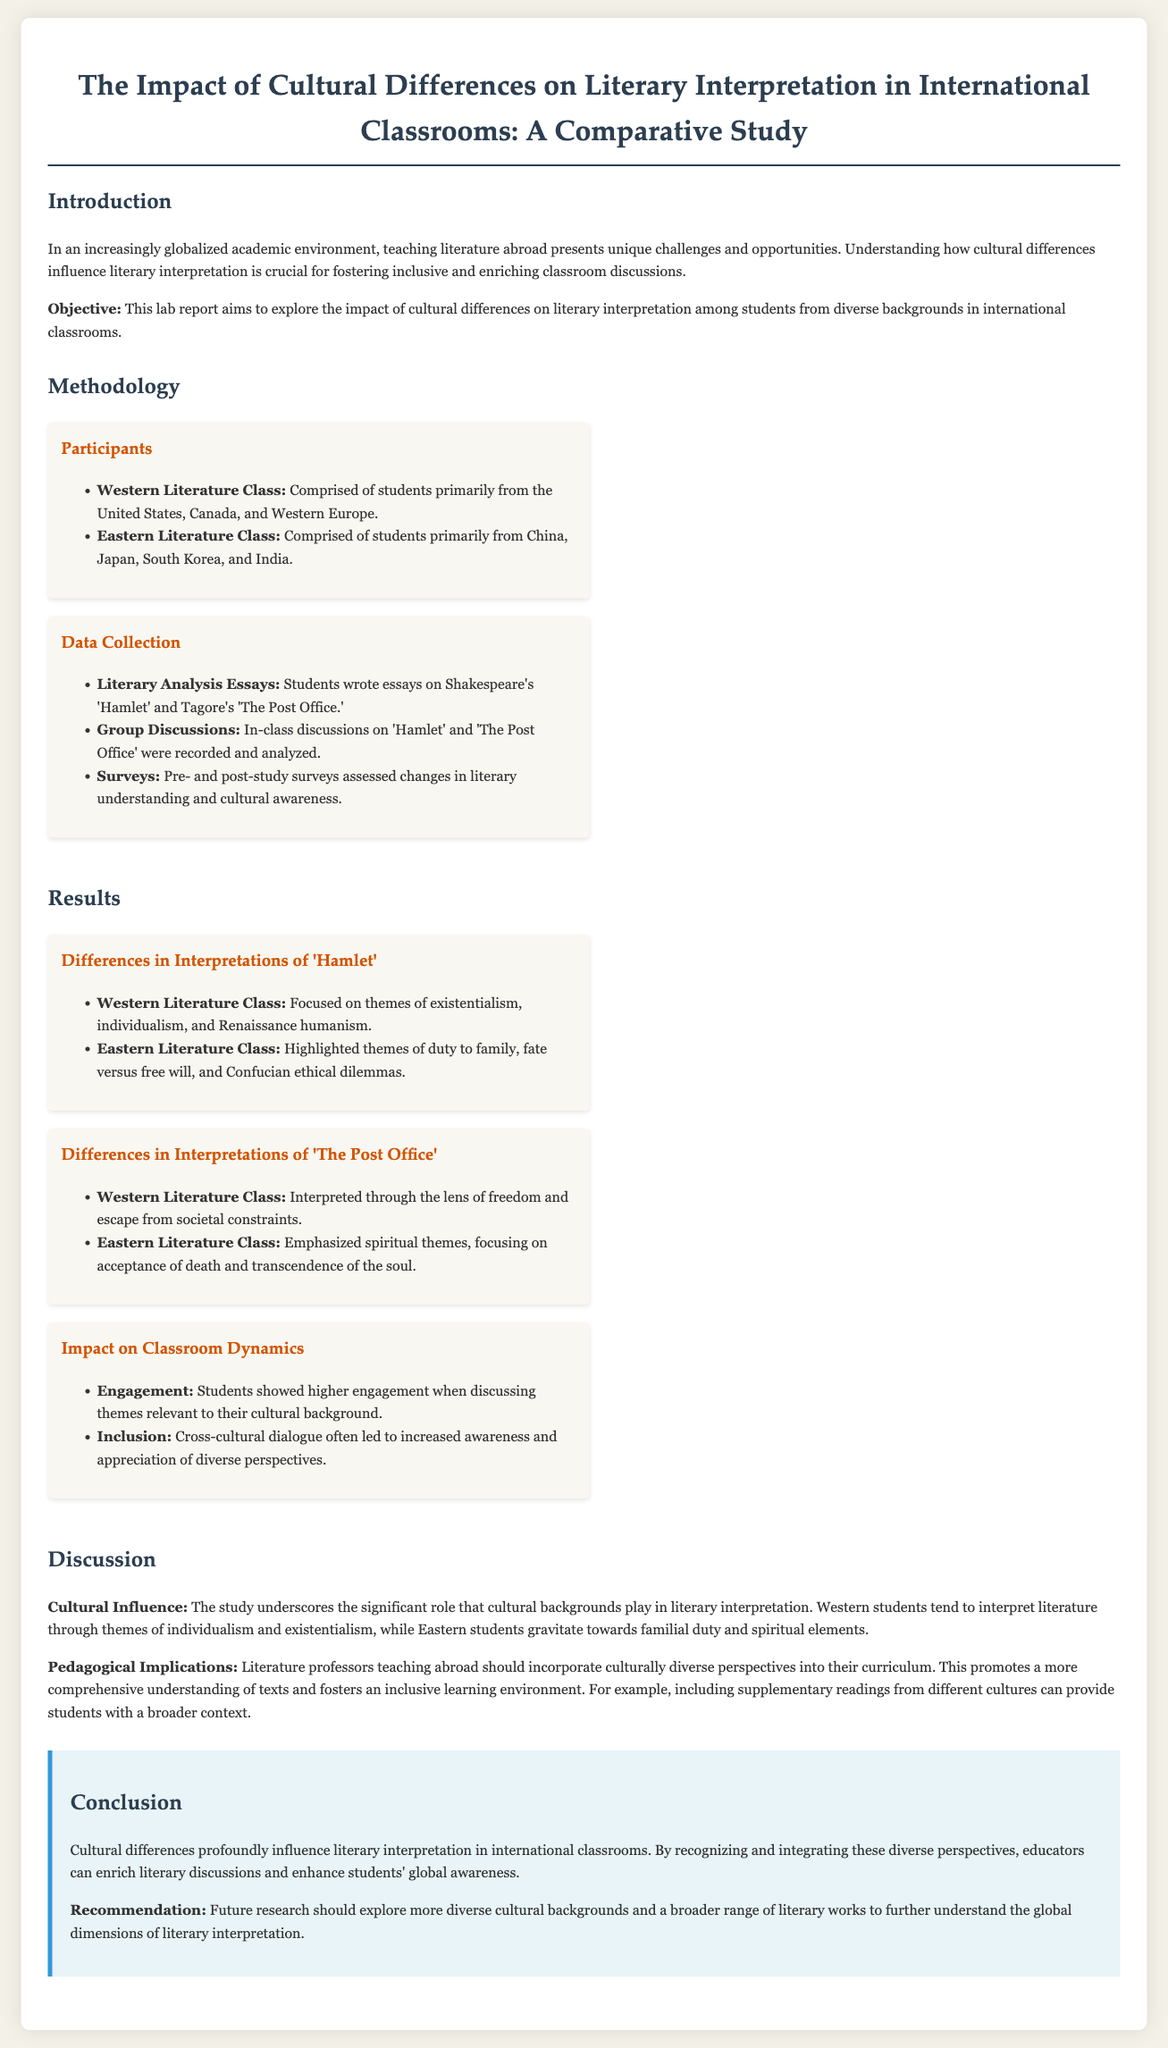What is the main objective of the study? The main objective is to explore the impact of cultural differences on literary interpretation among students from diverse backgrounds in international classrooms.
Answer: To explore the impact of cultural differences on literary interpretation How many classes of participants were involved in the study? The study involved two classes: Western Literature Class and Eastern Literature Class.
Answer: Two classes Which literary works were analyzed in the study? The literary works analyzed were Shakespeare's 'Hamlet' and Tagore's 'The Post Office.'
Answer: 'Hamlet' and 'The Post Office' What theme did Western students focus on in 'Hamlet'? Western students focused on themes of existentialism, individualism, and Renaissance humanism in 'Hamlet'.
Answer: Existentialism What cultural aspect did Eastern students emphasize in 'The Post Office'? Eastern students emphasized spiritual themes, focusing on acceptance of death and transcendence of the soul in 'The Post Office'.
Answer: Spiritual themes What was the impact on classroom dynamics according to the results? The results indicated that students showed higher engagement when discussing themes relevant to their cultural background.
Answer: Higher engagement What is one recommendation for future research mentioned in the conclusion? Future research should explore more diverse cultural backgrounds and a broader range of literary works.
Answer: Explore more diverse cultural backgrounds 